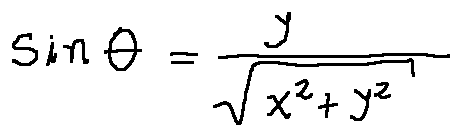<formula> <loc_0><loc_0><loc_500><loc_500>\sin \theta = \frac { y } { \sqrt { x ^ { 2 } + y ^ { 2 } } }</formula> 